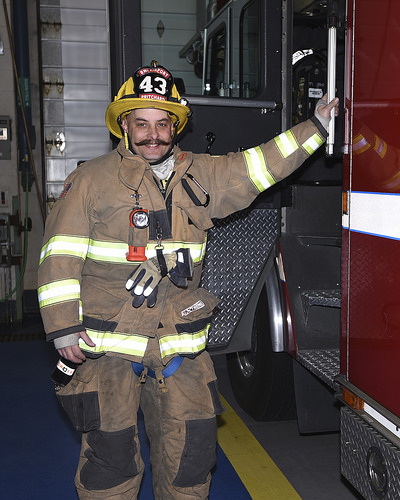<image>
Is there a flashlight in front of the suit? Yes. The flashlight is positioned in front of the suit, appearing closer to the camera viewpoint. 